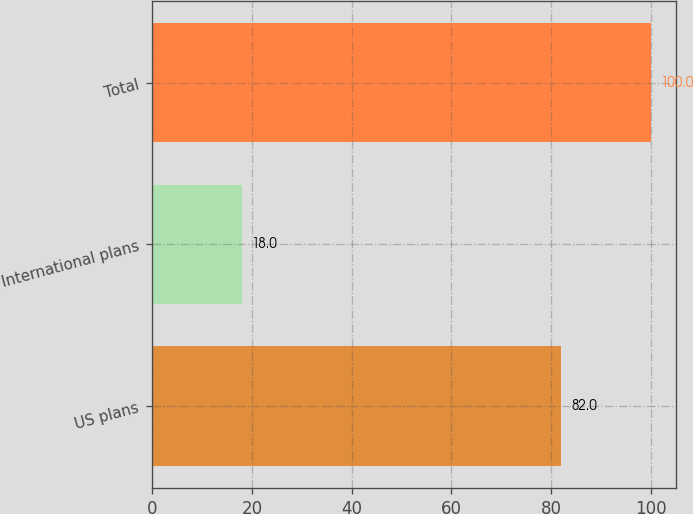Convert chart. <chart><loc_0><loc_0><loc_500><loc_500><bar_chart><fcel>US plans<fcel>International plans<fcel>Total<nl><fcel>82<fcel>18<fcel>100<nl></chart> 